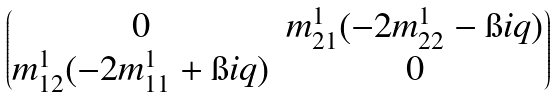<formula> <loc_0><loc_0><loc_500><loc_500>\begin{pmatrix} 0 & m ^ { 1 } _ { 2 1 } ( - 2 m ^ { 1 } _ { 2 2 } - \i i q ) \\ m ^ { 1 } _ { 1 2 } ( - 2 m ^ { 1 } _ { 1 1 } + \i i q ) & 0 \end{pmatrix}</formula> 